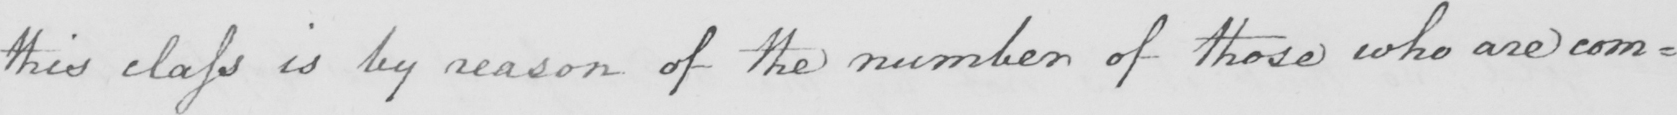Please transcribe the handwritten text in this image. this class is by reason of the number of those who are com= 